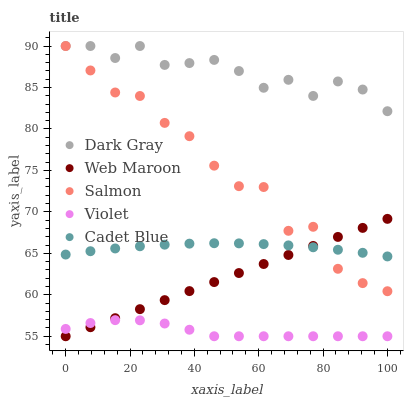Does Violet have the minimum area under the curve?
Answer yes or no. Yes. Does Dark Gray have the maximum area under the curve?
Answer yes or no. Yes. Does Salmon have the minimum area under the curve?
Answer yes or no. No. Does Salmon have the maximum area under the curve?
Answer yes or no. No. Is Web Maroon the smoothest?
Answer yes or no. Yes. Is Salmon the roughest?
Answer yes or no. Yes. Is Cadet Blue the smoothest?
Answer yes or no. No. Is Cadet Blue the roughest?
Answer yes or no. No. Does Web Maroon have the lowest value?
Answer yes or no. Yes. Does Salmon have the lowest value?
Answer yes or no. No. Does Salmon have the highest value?
Answer yes or no. Yes. Does Cadet Blue have the highest value?
Answer yes or no. No. Is Violet less than Cadet Blue?
Answer yes or no. Yes. Is Salmon greater than Violet?
Answer yes or no. Yes. Does Web Maroon intersect Salmon?
Answer yes or no. Yes. Is Web Maroon less than Salmon?
Answer yes or no. No. Is Web Maroon greater than Salmon?
Answer yes or no. No. Does Violet intersect Cadet Blue?
Answer yes or no. No. 